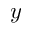<formula> <loc_0><loc_0><loc_500><loc_500>y</formula> 